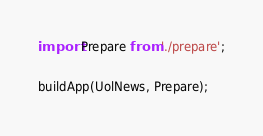<code> <loc_0><loc_0><loc_500><loc_500><_JavaScript_>import Prepare from './prepare';

buildApp(UolNews, Prepare);
</code> 